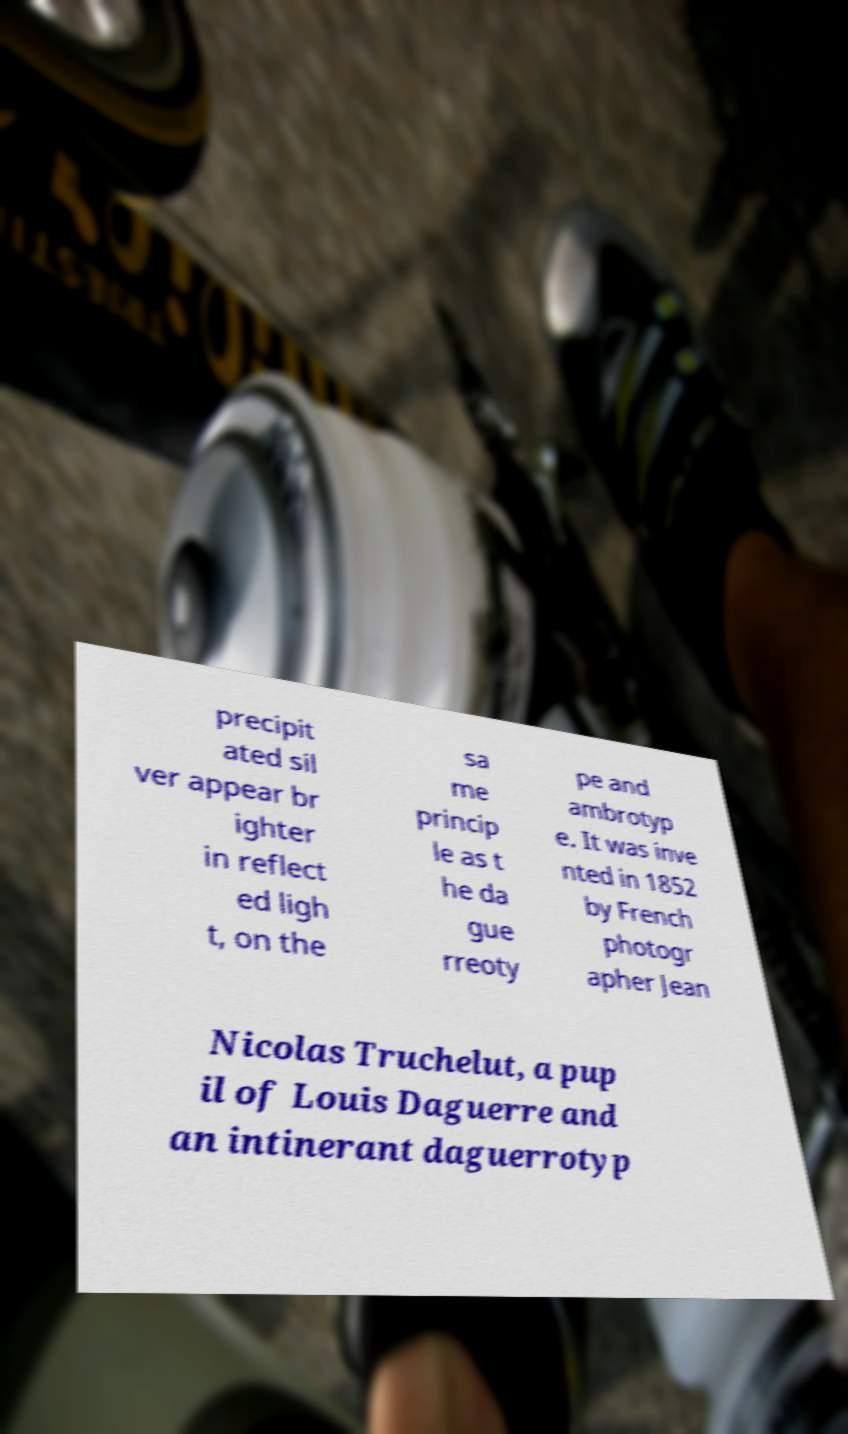I need the written content from this picture converted into text. Can you do that? precipit ated sil ver appear br ighter in reflect ed ligh t, on the sa me princip le as t he da gue rreoty pe and ambrotyp e. It was inve nted in 1852 by French photogr apher Jean Nicolas Truchelut, a pup il of Louis Daguerre and an intinerant daguerrotyp 